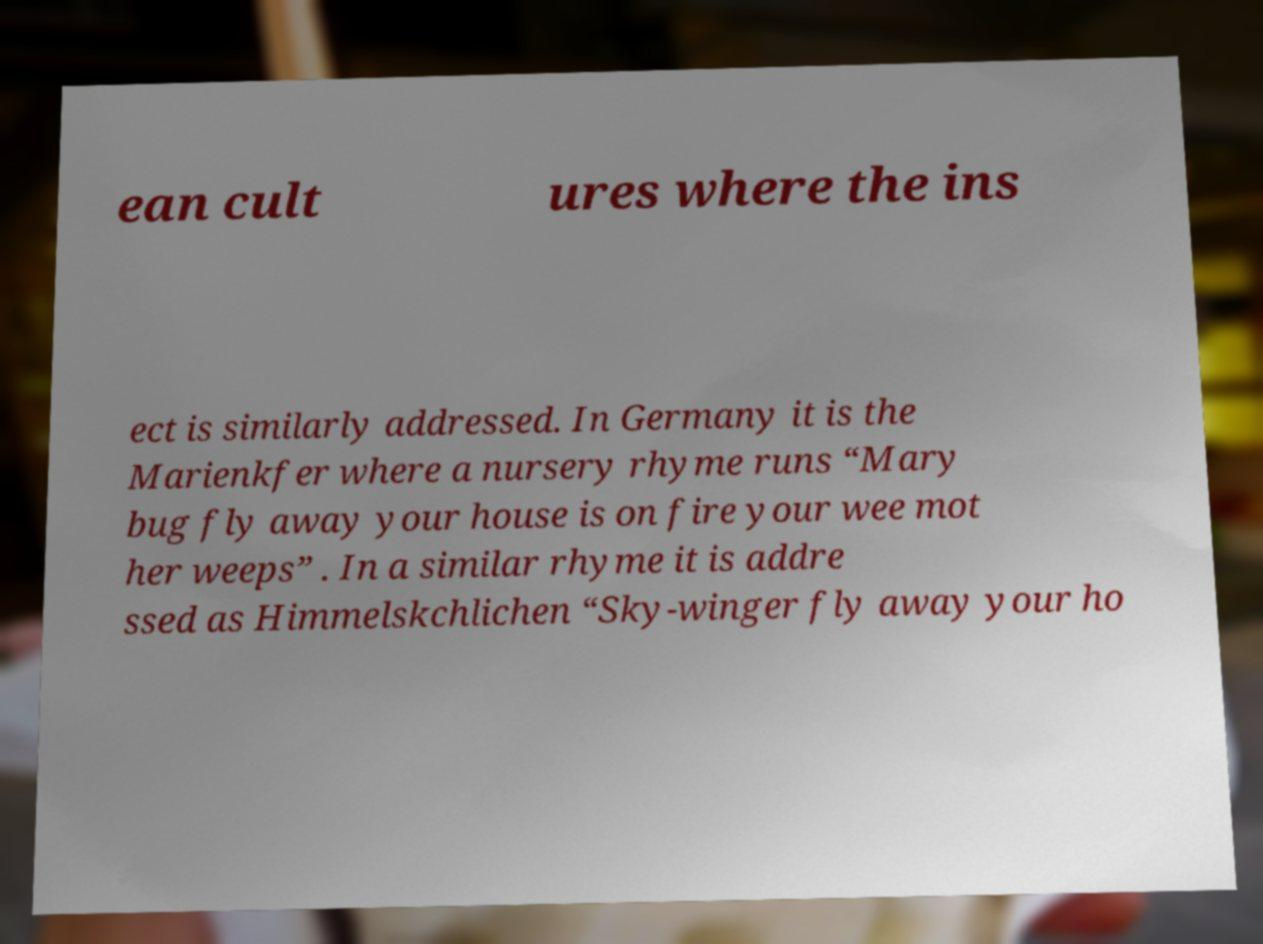Could you extract and type out the text from this image? ean cult ures where the ins ect is similarly addressed. In Germany it is the Marienkfer where a nursery rhyme runs “Mary bug fly away your house is on fire your wee mot her weeps” . In a similar rhyme it is addre ssed as Himmelskchlichen “Sky-winger fly away your ho 